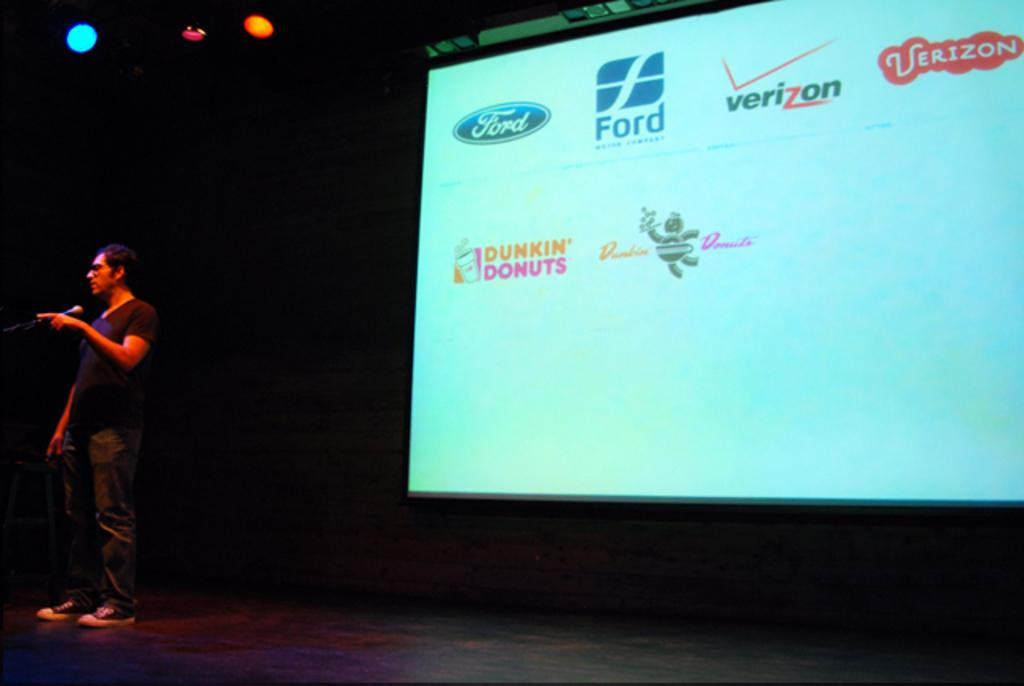Provide a one-sentence caption for the provided image. Two different logos for popular companies such as Ford and Dunkin Donuts appear on a screen. 